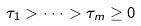Convert formula to latex. <formula><loc_0><loc_0><loc_500><loc_500>\tau _ { 1 } > \cdot \cdot \cdot > \tau _ { m } \geq 0</formula> 